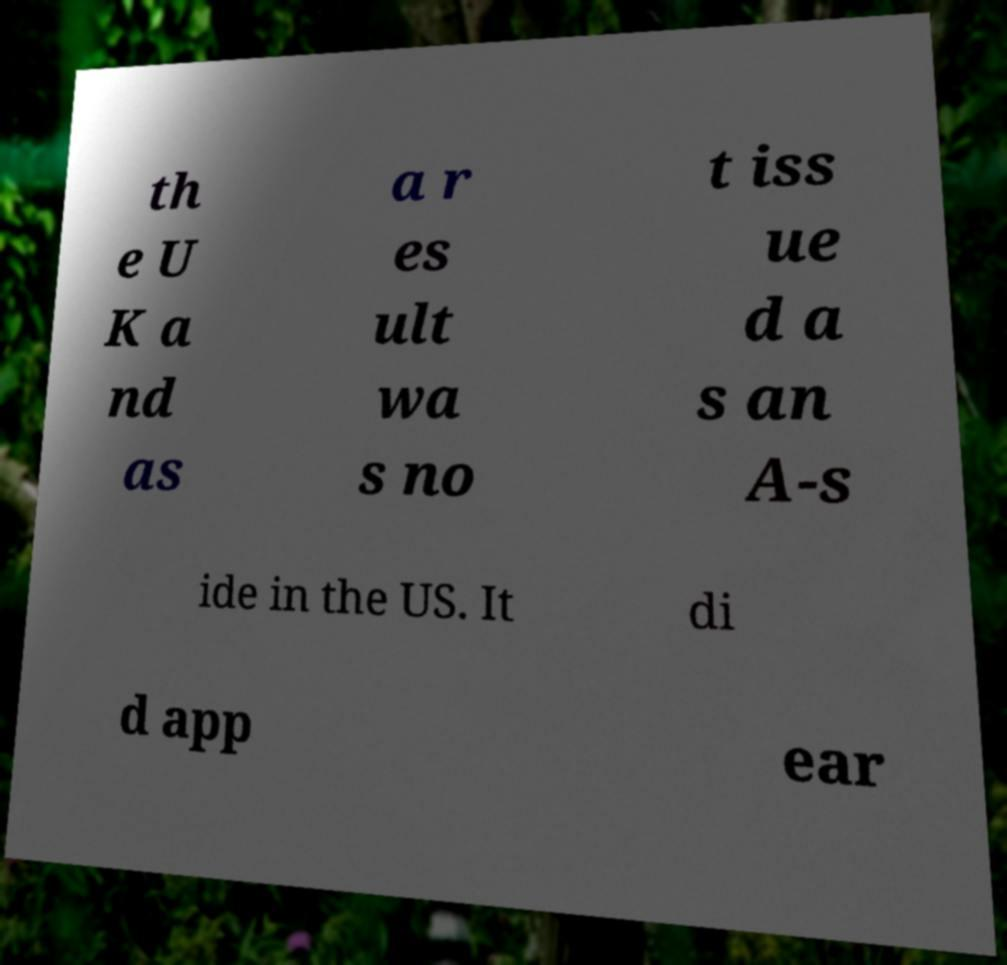Can you read and provide the text displayed in the image?This photo seems to have some interesting text. Can you extract and type it out for me? th e U K a nd as a r es ult wa s no t iss ue d a s an A-s ide in the US. It di d app ear 